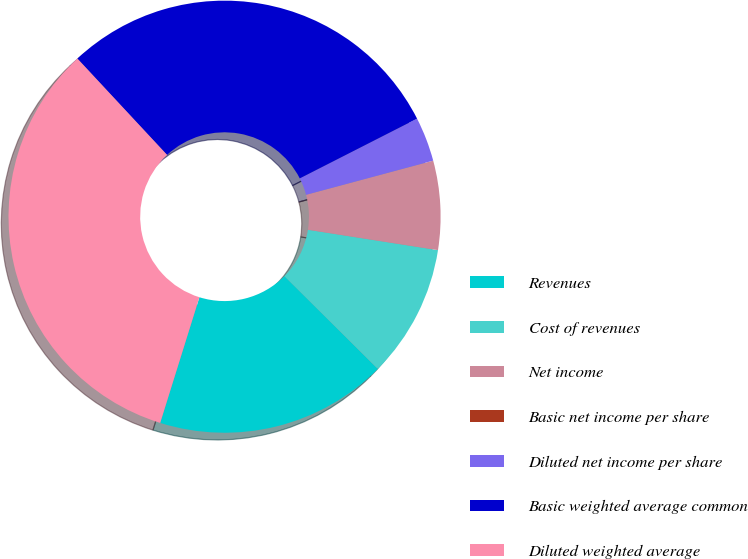Convert chart to OTSL. <chart><loc_0><loc_0><loc_500><loc_500><pie_chart><fcel>Revenues<fcel>Cost of revenues<fcel>Net income<fcel>Basic net income per share<fcel>Diluted net income per share<fcel>Basic weighted average common<fcel>Diluted weighted average<nl><fcel>17.37%<fcel>9.97%<fcel>6.65%<fcel>0.0%<fcel>3.32%<fcel>29.43%<fcel>33.25%<nl></chart> 